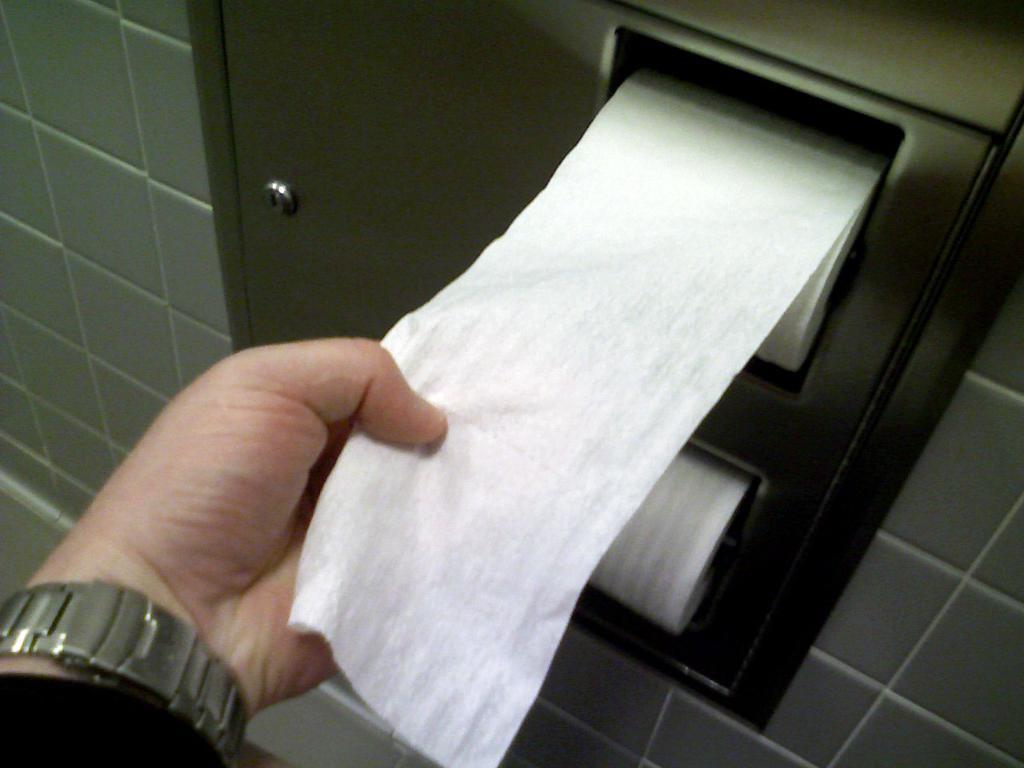Describe this image in one or two sentences. In this picture I can see a person's hand, this person is pulling the tissue roll, we can also see a wall. 